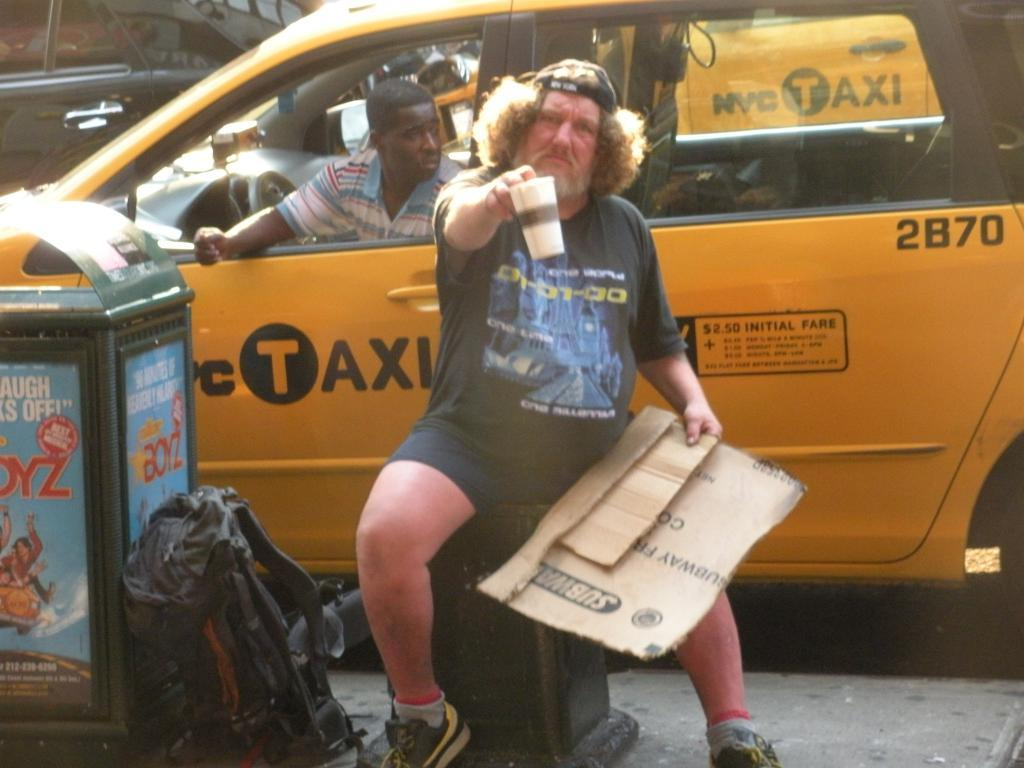<image>
Give a short and clear explanation of the subsequent image. An unkempt man holds out a cup while holding cardboard next to a yellow NYC Taxi van. 